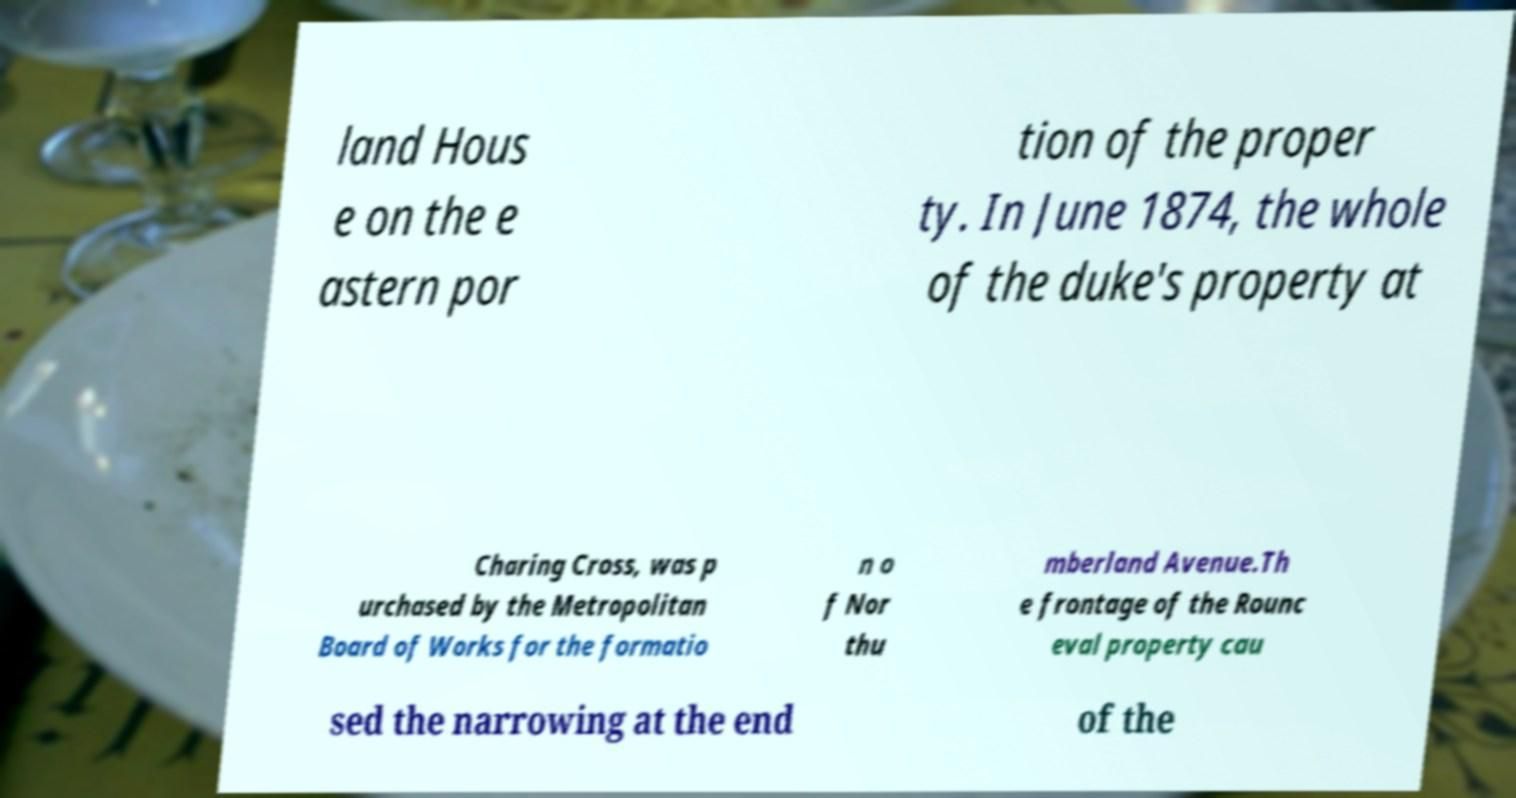Please identify and transcribe the text found in this image. land Hous e on the e astern por tion of the proper ty. In June 1874, the whole of the duke's property at Charing Cross, was p urchased by the Metropolitan Board of Works for the formatio n o f Nor thu mberland Avenue.Th e frontage of the Rounc eval property cau sed the narrowing at the end of the 